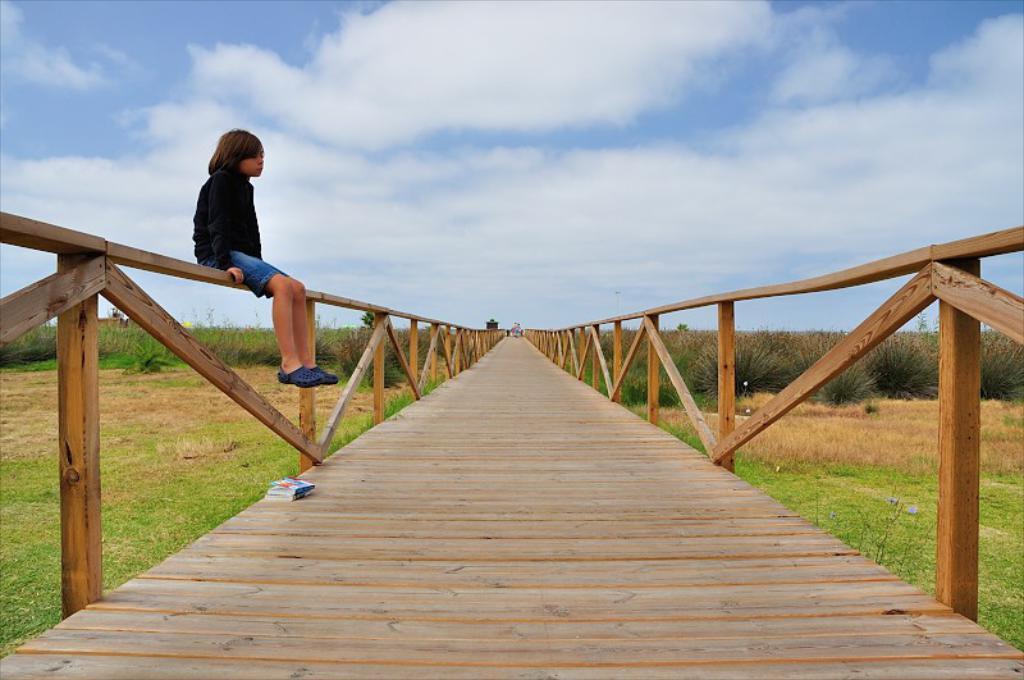Describe this image in one or two sentences. In the image there is a kid in black dress sitting on fence of wooden bridge and on either side there is grassland and above its sky with clouds. 